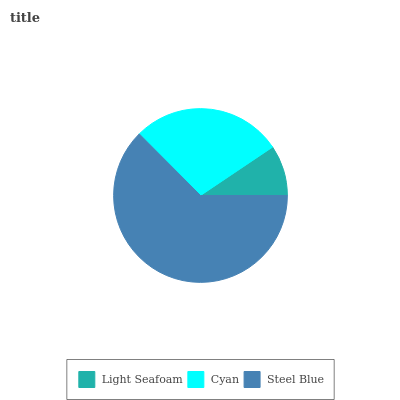Is Light Seafoam the minimum?
Answer yes or no. Yes. Is Steel Blue the maximum?
Answer yes or no. Yes. Is Cyan the minimum?
Answer yes or no. No. Is Cyan the maximum?
Answer yes or no. No. Is Cyan greater than Light Seafoam?
Answer yes or no. Yes. Is Light Seafoam less than Cyan?
Answer yes or no. Yes. Is Light Seafoam greater than Cyan?
Answer yes or no. No. Is Cyan less than Light Seafoam?
Answer yes or no. No. Is Cyan the high median?
Answer yes or no. Yes. Is Cyan the low median?
Answer yes or no. Yes. Is Light Seafoam the high median?
Answer yes or no. No. Is Steel Blue the low median?
Answer yes or no. No. 